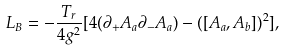<formula> <loc_0><loc_0><loc_500><loc_500>L _ { B } = - \frac { T _ { r } } { 4 g ^ { 2 } } [ 4 ( \partial _ { + } A _ { a } \partial _ { - } A _ { a } ) - ( [ A _ { a } , A _ { b } ] ) ^ { 2 } ] ,</formula> 